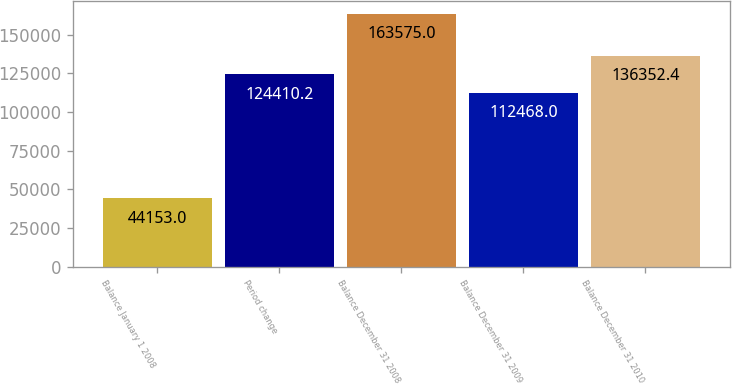Convert chart. <chart><loc_0><loc_0><loc_500><loc_500><bar_chart><fcel>Balance January 1 2008<fcel>Period change<fcel>Balance December 31 2008<fcel>Balance December 31 2009<fcel>Balance December 31 2010<nl><fcel>44153<fcel>124410<fcel>163575<fcel>112468<fcel>136352<nl></chart> 